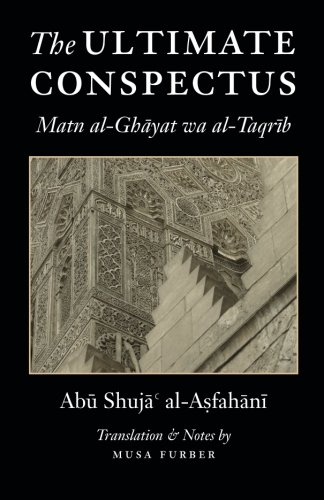What is the title of this book? The title of this book is 'The Ultimate Conspectus: Matn al-Ghayat wa al-Taqrib,' which explores key concepts in Islamic legal theories. 